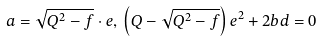<formula> <loc_0><loc_0><loc_500><loc_500>a = \sqrt { Q ^ { 2 } - f } \cdot e , \, \left ( Q - \sqrt { Q ^ { 2 } - f } \right ) e ^ { 2 } + 2 b d = 0</formula> 